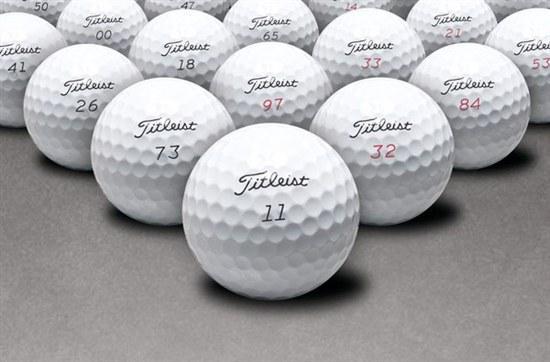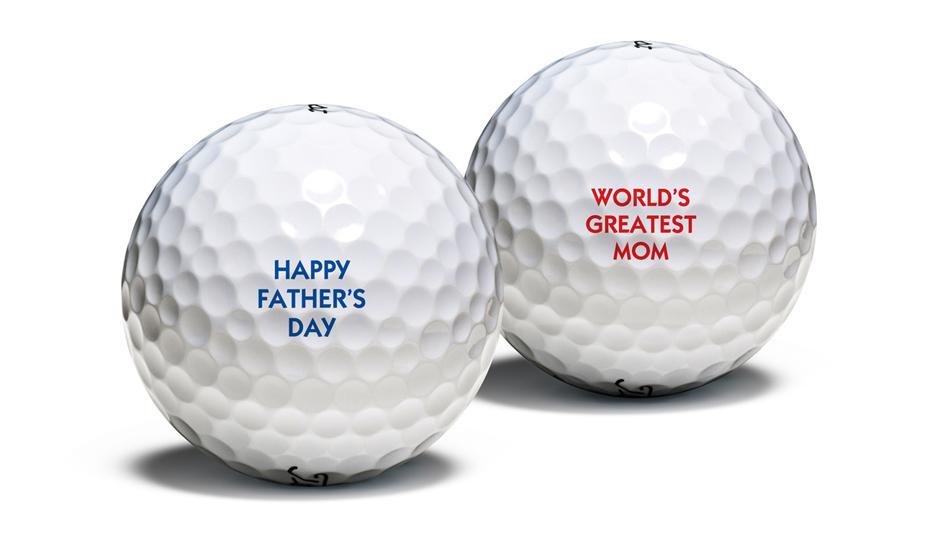The first image is the image on the left, the second image is the image on the right. Evaluate the accuracy of this statement regarding the images: "The golfballs in one photo appear dirty from use.". Is it true? Answer yes or no. No. The first image is the image on the left, the second image is the image on the right. Assess this claim about the two images: "Some of the golf balls are off white due to dirt.". Correct or not? Answer yes or no. No. The first image is the image on the left, the second image is the image on the right. For the images displayed, is the sentence "One image shows only cleaned golf balls and the other image includes dirty golf balls." factually correct? Answer yes or no. No. The first image is the image on the left, the second image is the image on the right. Considering the images on both sides, is "One of the images includes dirty, used golf balls." valid? Answer yes or no. No. 